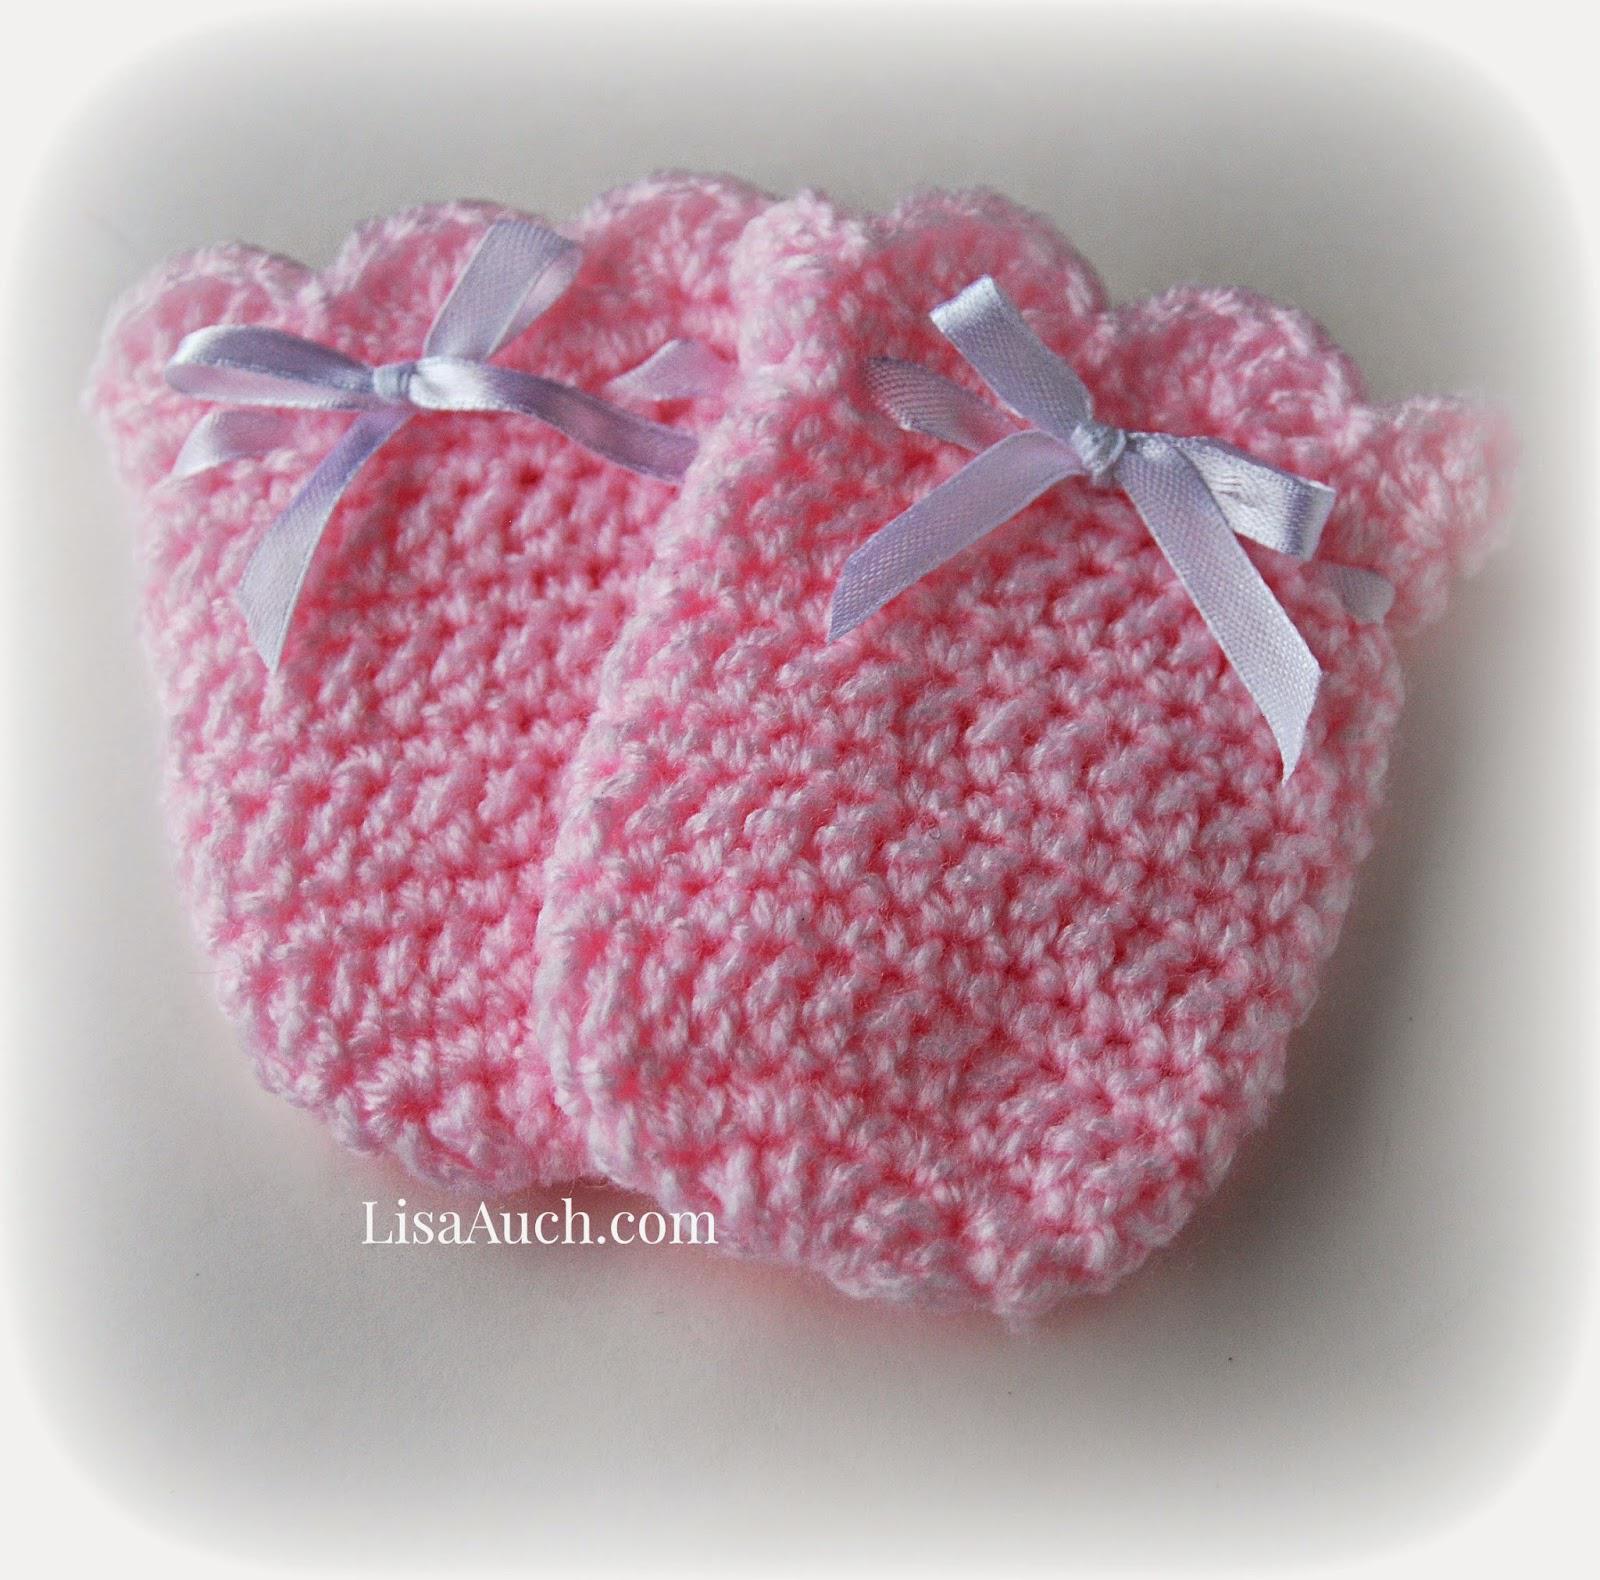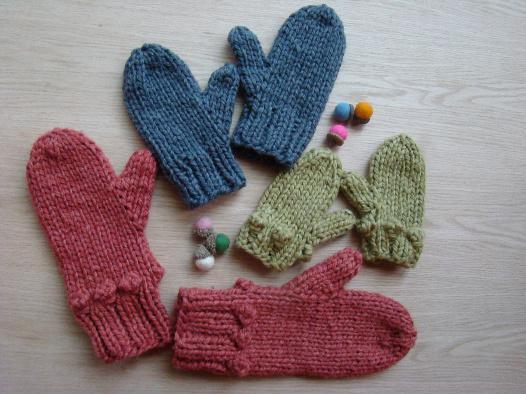The first image is the image on the left, the second image is the image on the right. Given the left and right images, does the statement "There are at least 3 pairs of mittens all a different color." hold true? Answer yes or no. Yes. The first image is the image on the left, the second image is the image on the right. Given the left and right images, does the statement "Each image contains at least two baby mittens, and no mittens have separate thumb sections." hold true? Answer yes or no. No. 